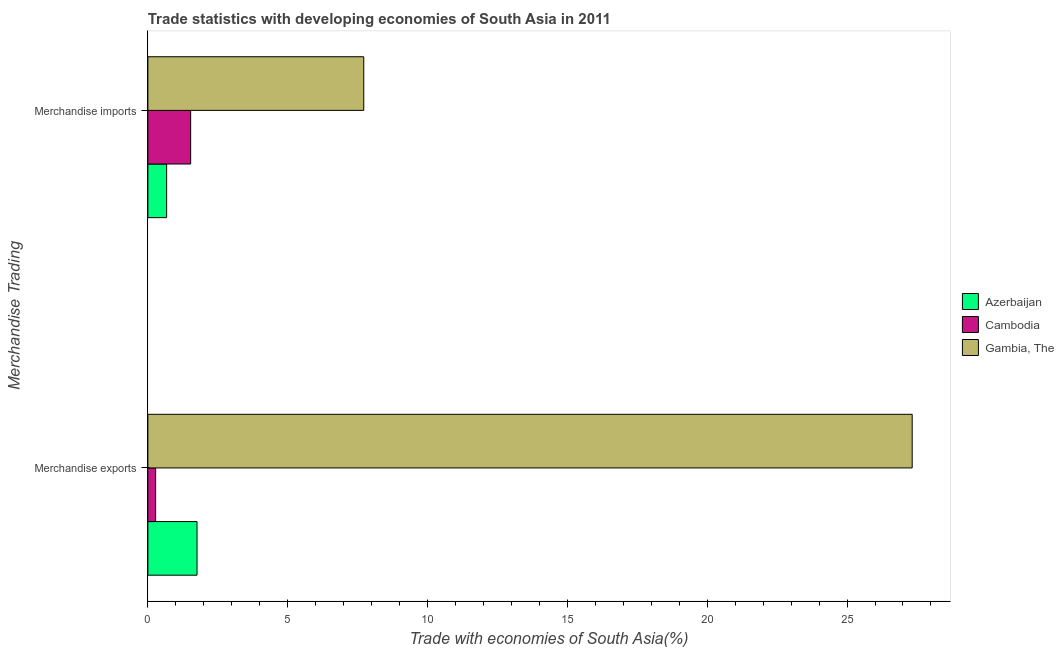How many bars are there on the 2nd tick from the top?
Provide a succinct answer. 3. How many bars are there on the 2nd tick from the bottom?
Offer a terse response. 3. What is the merchandise exports in Cambodia?
Ensure brevity in your answer.  0.28. Across all countries, what is the maximum merchandise imports?
Your answer should be compact. 7.72. Across all countries, what is the minimum merchandise imports?
Offer a terse response. 0.67. In which country was the merchandise exports maximum?
Give a very brief answer. Gambia, The. In which country was the merchandise imports minimum?
Make the answer very short. Azerbaijan. What is the total merchandise exports in the graph?
Provide a short and direct response. 29.36. What is the difference between the merchandise imports in Azerbaijan and that in Gambia, The?
Ensure brevity in your answer.  -7.05. What is the difference between the merchandise imports in Azerbaijan and the merchandise exports in Cambodia?
Offer a terse response. 0.39. What is the average merchandise exports per country?
Your answer should be compact. 9.79. What is the difference between the merchandise imports and merchandise exports in Cambodia?
Offer a very short reply. 1.25. What is the ratio of the merchandise imports in Cambodia to that in Azerbaijan?
Your answer should be very brief. 2.28. Is the merchandise exports in Cambodia less than that in Gambia, The?
Give a very brief answer. Yes. In how many countries, is the merchandise exports greater than the average merchandise exports taken over all countries?
Your answer should be very brief. 1. What does the 1st bar from the top in Merchandise exports represents?
Make the answer very short. Gambia, The. What does the 1st bar from the bottom in Merchandise imports represents?
Your answer should be compact. Azerbaijan. How many bars are there?
Keep it short and to the point. 6. Are all the bars in the graph horizontal?
Ensure brevity in your answer.  Yes. What is the difference between two consecutive major ticks on the X-axis?
Give a very brief answer. 5. Does the graph contain any zero values?
Provide a succinct answer. No. Does the graph contain grids?
Your answer should be compact. No. Where does the legend appear in the graph?
Your answer should be compact. Center right. How many legend labels are there?
Offer a terse response. 3. How are the legend labels stacked?
Your response must be concise. Vertical. What is the title of the graph?
Give a very brief answer. Trade statistics with developing economies of South Asia in 2011. Does "Chile" appear as one of the legend labels in the graph?
Give a very brief answer. No. What is the label or title of the X-axis?
Your response must be concise. Trade with economies of South Asia(%). What is the label or title of the Y-axis?
Offer a terse response. Merchandise Trading. What is the Trade with economies of South Asia(%) in Azerbaijan in Merchandise exports?
Your answer should be very brief. 1.76. What is the Trade with economies of South Asia(%) in Cambodia in Merchandise exports?
Keep it short and to the point. 0.28. What is the Trade with economies of South Asia(%) in Gambia, The in Merchandise exports?
Your answer should be compact. 27.33. What is the Trade with economies of South Asia(%) in Azerbaijan in Merchandise imports?
Provide a short and direct response. 0.67. What is the Trade with economies of South Asia(%) of Cambodia in Merchandise imports?
Offer a terse response. 1.53. What is the Trade with economies of South Asia(%) in Gambia, The in Merchandise imports?
Give a very brief answer. 7.72. Across all Merchandise Trading, what is the maximum Trade with economies of South Asia(%) in Azerbaijan?
Give a very brief answer. 1.76. Across all Merchandise Trading, what is the maximum Trade with economies of South Asia(%) of Cambodia?
Offer a very short reply. 1.53. Across all Merchandise Trading, what is the maximum Trade with economies of South Asia(%) in Gambia, The?
Your response must be concise. 27.33. Across all Merchandise Trading, what is the minimum Trade with economies of South Asia(%) in Azerbaijan?
Keep it short and to the point. 0.67. Across all Merchandise Trading, what is the minimum Trade with economies of South Asia(%) in Cambodia?
Your answer should be very brief. 0.28. Across all Merchandise Trading, what is the minimum Trade with economies of South Asia(%) of Gambia, The?
Offer a terse response. 7.72. What is the total Trade with economies of South Asia(%) in Azerbaijan in the graph?
Provide a short and direct response. 2.43. What is the total Trade with economies of South Asia(%) of Cambodia in the graph?
Give a very brief answer. 1.81. What is the total Trade with economies of South Asia(%) in Gambia, The in the graph?
Provide a succinct answer. 35.05. What is the difference between the Trade with economies of South Asia(%) in Azerbaijan in Merchandise exports and that in Merchandise imports?
Provide a succinct answer. 1.09. What is the difference between the Trade with economies of South Asia(%) of Cambodia in Merchandise exports and that in Merchandise imports?
Your answer should be very brief. -1.25. What is the difference between the Trade with economies of South Asia(%) of Gambia, The in Merchandise exports and that in Merchandise imports?
Offer a very short reply. 19.61. What is the difference between the Trade with economies of South Asia(%) in Azerbaijan in Merchandise exports and the Trade with economies of South Asia(%) in Cambodia in Merchandise imports?
Offer a terse response. 0.23. What is the difference between the Trade with economies of South Asia(%) of Azerbaijan in Merchandise exports and the Trade with economies of South Asia(%) of Gambia, The in Merchandise imports?
Provide a short and direct response. -5.96. What is the difference between the Trade with economies of South Asia(%) of Cambodia in Merchandise exports and the Trade with economies of South Asia(%) of Gambia, The in Merchandise imports?
Offer a very short reply. -7.44. What is the average Trade with economies of South Asia(%) of Azerbaijan per Merchandise Trading?
Provide a succinct answer. 1.21. What is the average Trade with economies of South Asia(%) of Cambodia per Merchandise Trading?
Offer a very short reply. 0.9. What is the average Trade with economies of South Asia(%) in Gambia, The per Merchandise Trading?
Make the answer very short. 17.52. What is the difference between the Trade with economies of South Asia(%) of Azerbaijan and Trade with economies of South Asia(%) of Cambodia in Merchandise exports?
Your answer should be very brief. 1.48. What is the difference between the Trade with economies of South Asia(%) of Azerbaijan and Trade with economies of South Asia(%) of Gambia, The in Merchandise exports?
Your answer should be very brief. -25.57. What is the difference between the Trade with economies of South Asia(%) in Cambodia and Trade with economies of South Asia(%) in Gambia, The in Merchandise exports?
Ensure brevity in your answer.  -27.05. What is the difference between the Trade with economies of South Asia(%) of Azerbaijan and Trade with economies of South Asia(%) of Cambodia in Merchandise imports?
Offer a terse response. -0.86. What is the difference between the Trade with economies of South Asia(%) in Azerbaijan and Trade with economies of South Asia(%) in Gambia, The in Merchandise imports?
Offer a very short reply. -7.05. What is the difference between the Trade with economies of South Asia(%) in Cambodia and Trade with economies of South Asia(%) in Gambia, The in Merchandise imports?
Give a very brief answer. -6.19. What is the ratio of the Trade with economies of South Asia(%) of Azerbaijan in Merchandise exports to that in Merchandise imports?
Keep it short and to the point. 2.62. What is the ratio of the Trade with economies of South Asia(%) of Cambodia in Merchandise exports to that in Merchandise imports?
Give a very brief answer. 0.18. What is the ratio of the Trade with economies of South Asia(%) in Gambia, The in Merchandise exports to that in Merchandise imports?
Provide a succinct answer. 3.54. What is the difference between the highest and the second highest Trade with economies of South Asia(%) of Azerbaijan?
Offer a terse response. 1.09. What is the difference between the highest and the second highest Trade with economies of South Asia(%) of Cambodia?
Your response must be concise. 1.25. What is the difference between the highest and the second highest Trade with economies of South Asia(%) of Gambia, The?
Give a very brief answer. 19.61. What is the difference between the highest and the lowest Trade with economies of South Asia(%) in Azerbaijan?
Keep it short and to the point. 1.09. What is the difference between the highest and the lowest Trade with economies of South Asia(%) of Cambodia?
Provide a succinct answer. 1.25. What is the difference between the highest and the lowest Trade with economies of South Asia(%) in Gambia, The?
Offer a terse response. 19.61. 